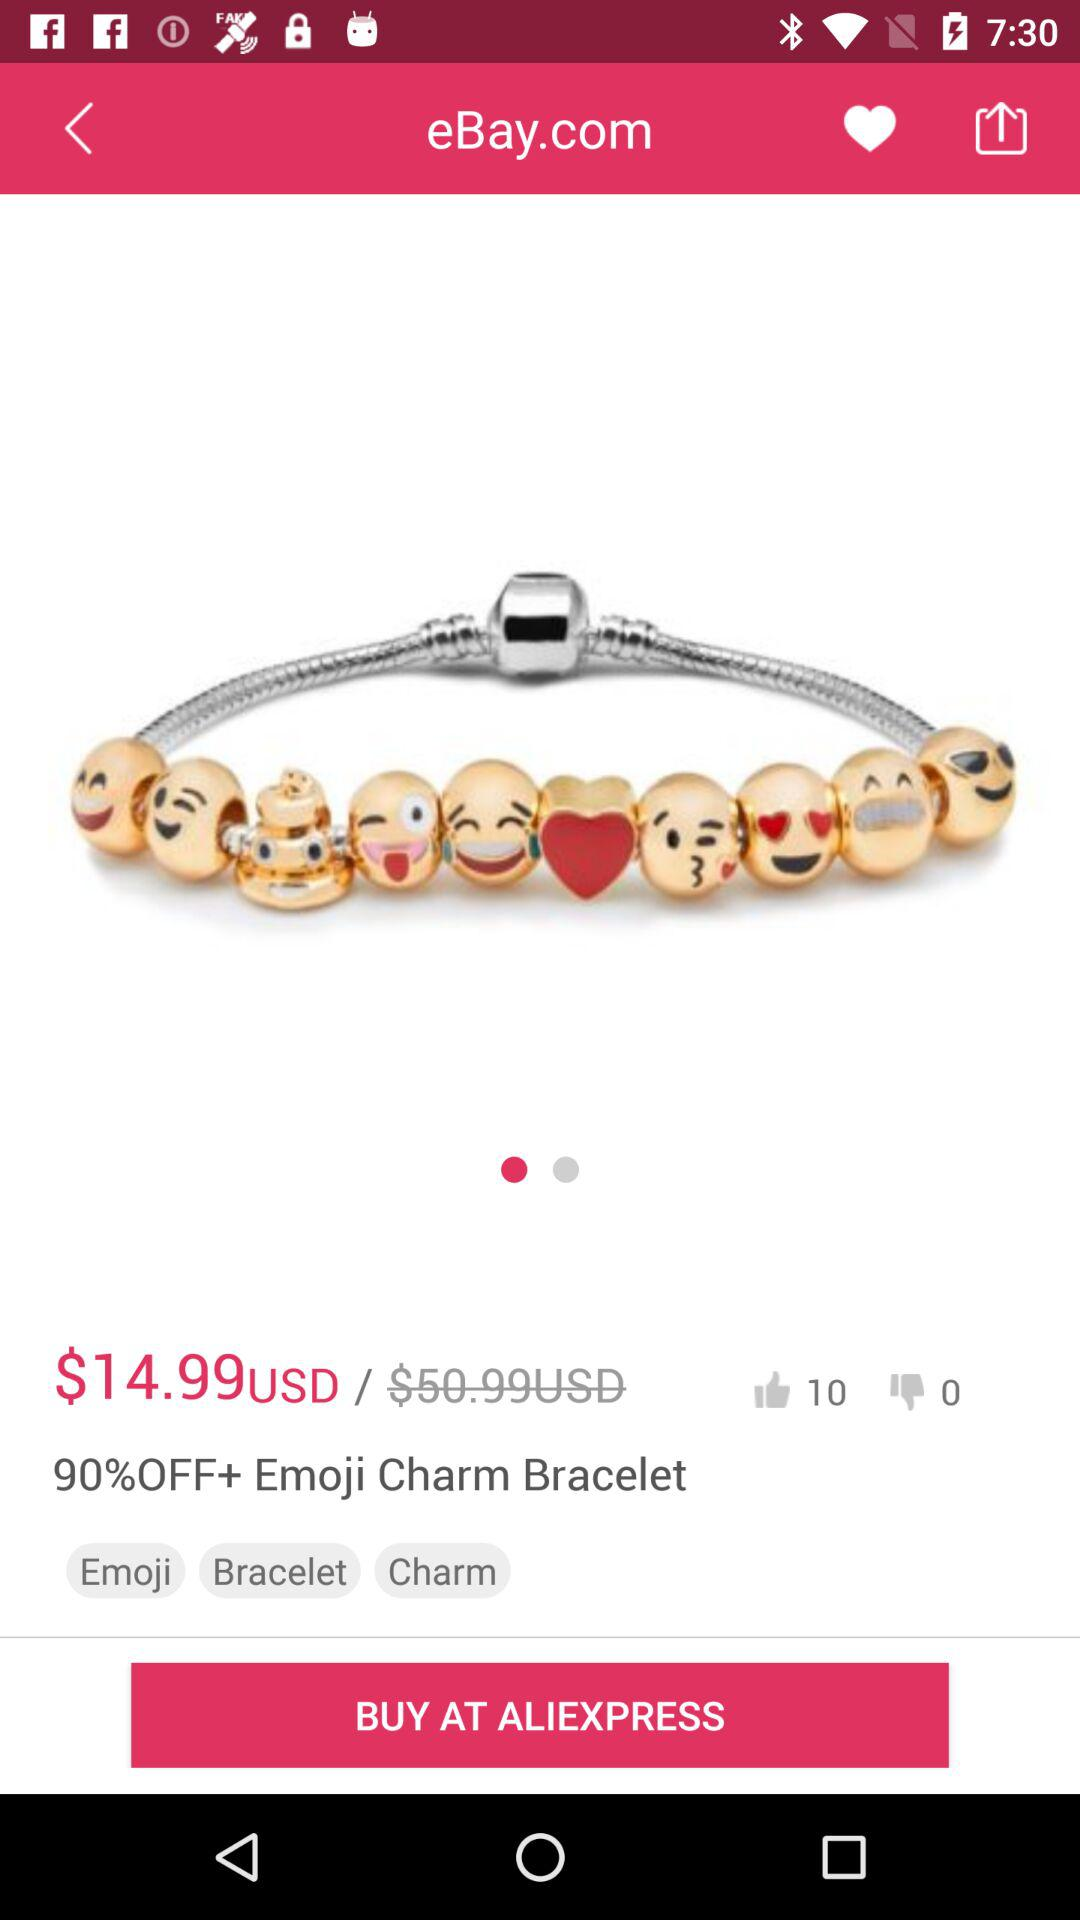What is the price of the "Emoji Charm Bracelet"? The price is $14.99 USD. 